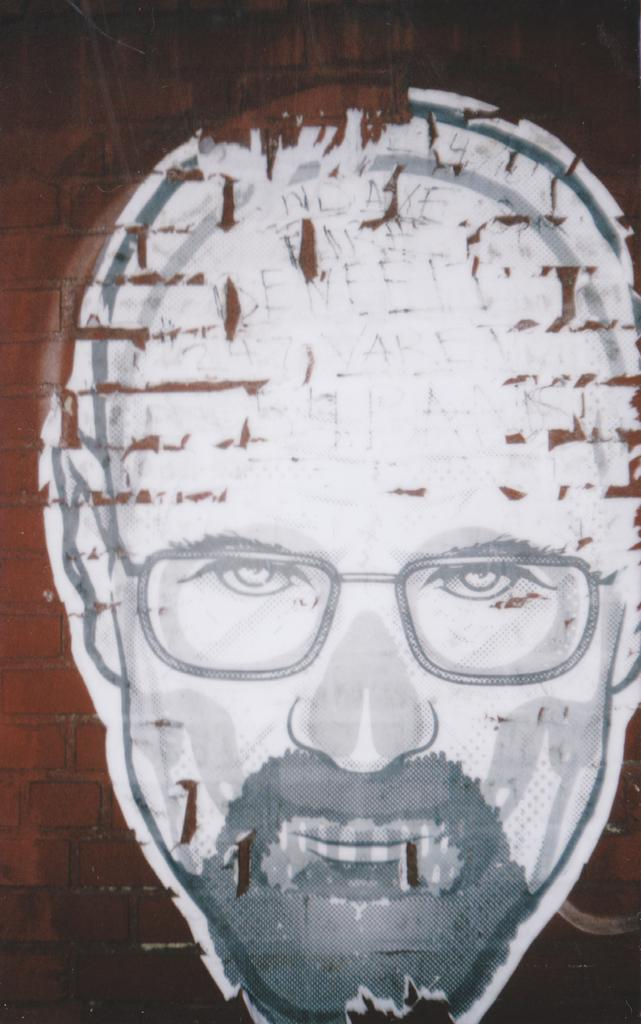What is the main subject of the painting in the image? The painting depicts the face of a man. Where is the painting located in the image? The painting is on a wall. Can you tell me how many chickens are in the painting? There are no chickens present in the painting; it depicts the face of a man. 